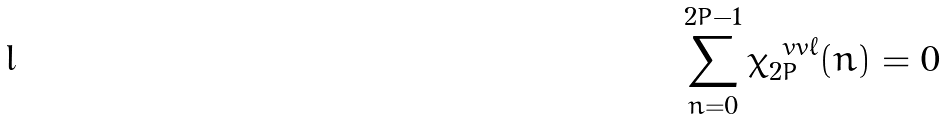Convert formula to latex. <formula><loc_0><loc_0><loc_500><loc_500>\sum _ { n = 0 } ^ { 2 P - 1 } \chi _ { 2 P } ^ { \ v v { \ell } } ( n ) = 0</formula> 